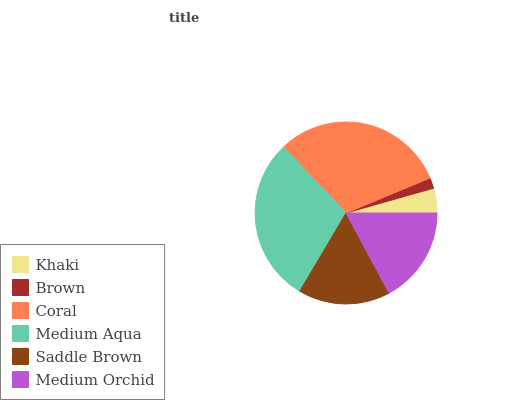Is Brown the minimum?
Answer yes or no. Yes. Is Coral the maximum?
Answer yes or no. Yes. Is Coral the minimum?
Answer yes or no. No. Is Brown the maximum?
Answer yes or no. No. Is Coral greater than Brown?
Answer yes or no. Yes. Is Brown less than Coral?
Answer yes or no. Yes. Is Brown greater than Coral?
Answer yes or no. No. Is Coral less than Brown?
Answer yes or no. No. Is Medium Orchid the high median?
Answer yes or no. Yes. Is Saddle Brown the low median?
Answer yes or no. Yes. Is Medium Aqua the high median?
Answer yes or no. No. Is Medium Orchid the low median?
Answer yes or no. No. 